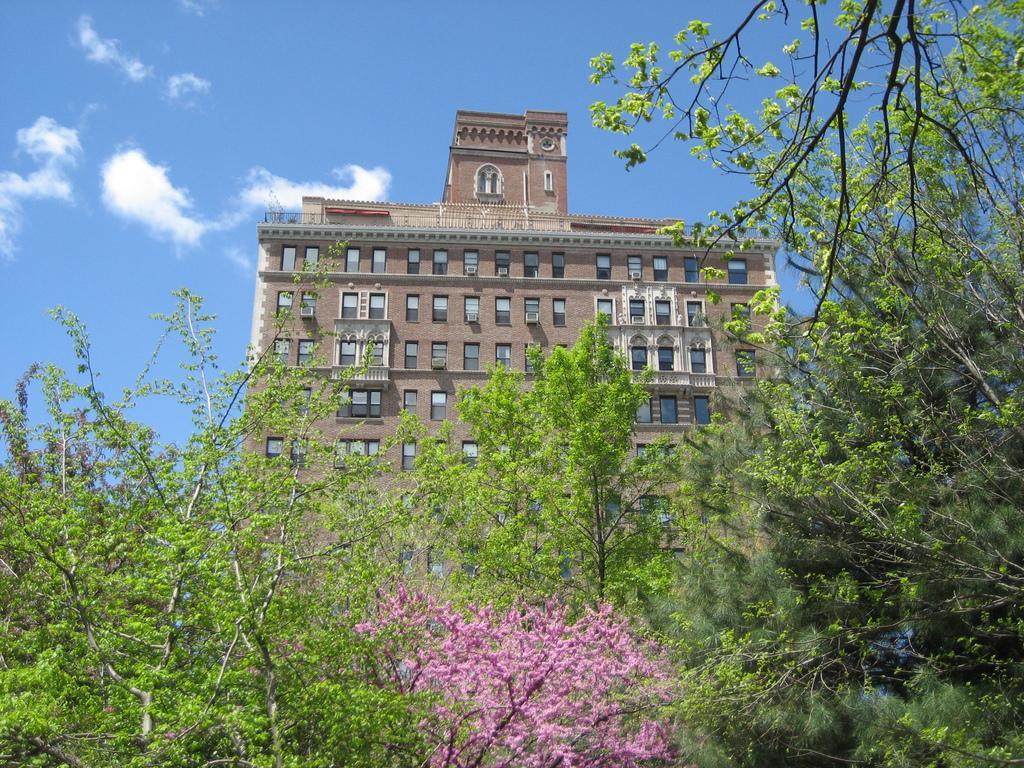Describe this image in one or two sentences. In the center of the image there is a building. At the bottom we can see trees. In the background there is sky. 